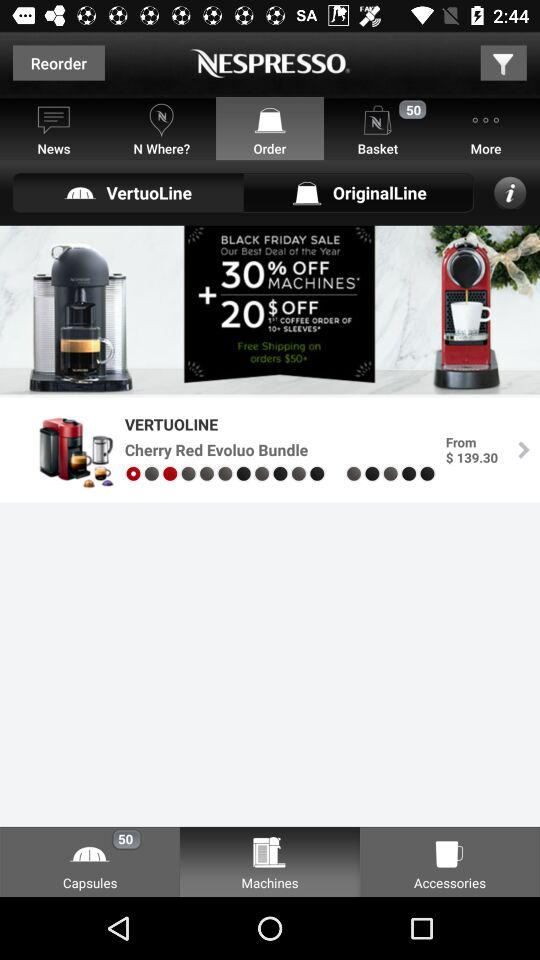How many capsules are available in the bundle?
Answer the question using a single word or phrase. 50 